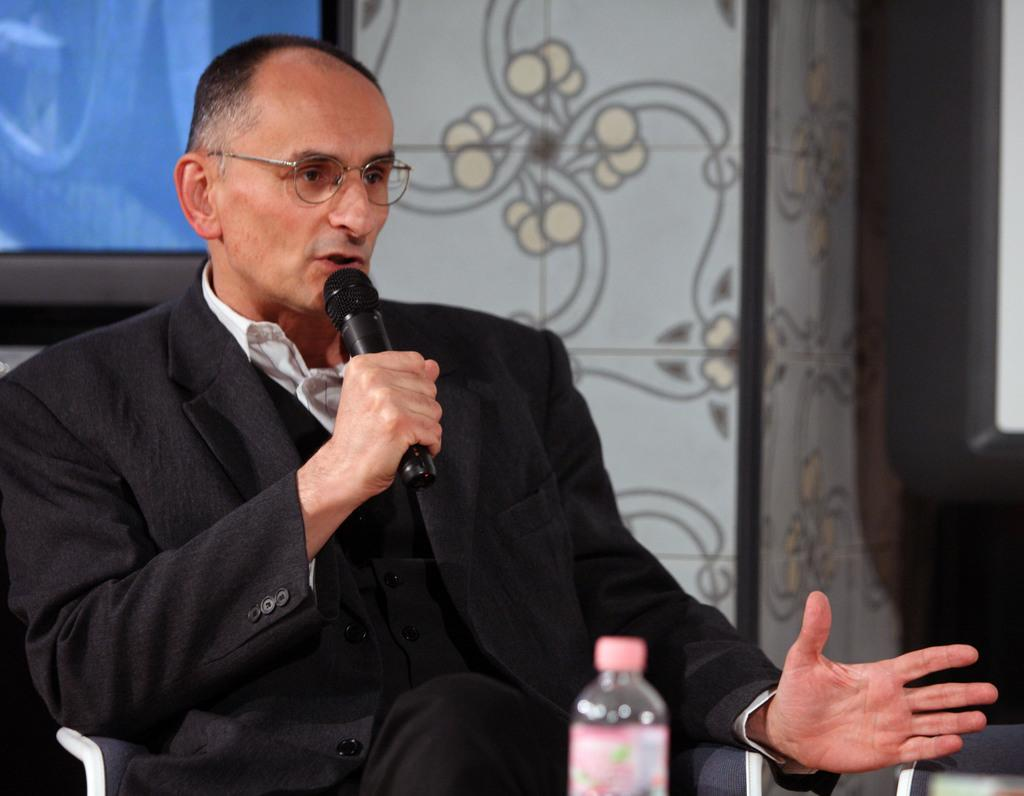Who is the main subject in the image? There is a person in the image. What is the person doing in the image? The person is sitting and talking on a microphone. What is placed in front of the person? There is a bottle in front of the person. What is visible behind the person? There is a screen behind the person. What type of banana is being compared to the substance on the screen? There is no banana or substance present in the image. 